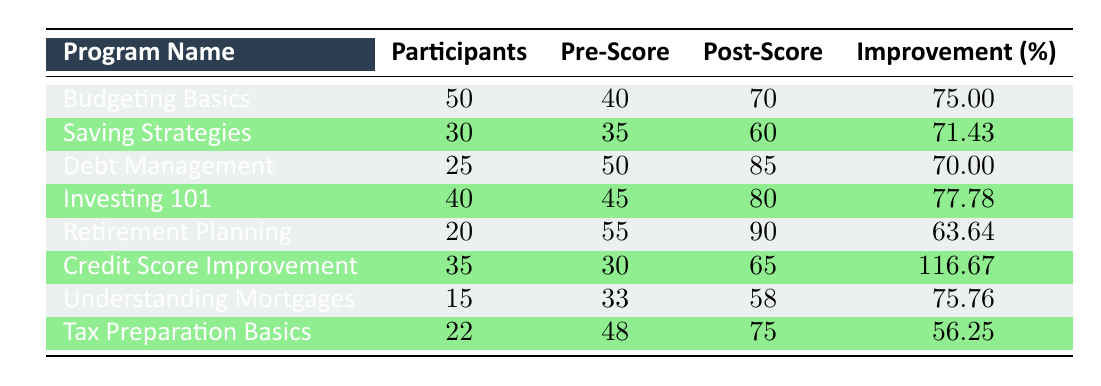What is the highest improvement percentage among the programs? The improvement percentages from the table are: Budgeting Basics (75.00), Saving Strategies (71.43), Debt Management (70.00), Investing 101 (77.78), Retirement Planning (63.64), Credit Score Improvement (116.67), Understanding Mortgages (75.76), and Tax Preparation Basics (56.25). The highest value is 116.67 from the Credit Score Improvement program.
Answer: 116.67 How many participants attended the Saving Strategies program? Looking at the table, the entry for Saving Strategies indicates that there were 30 participants.
Answer: 30 Did the Debt Management program have a post-assessment score higher than 80? From the table, the post-assessment score for the Debt Management program is 85, which is indeed higher than 80.
Answer: Yes What is the average improvement percentage of all the programs listed? First, sum up all the improvement percentages: 75.00 + 71.43 + 70.00 + 77.78 + 63.64 + 116.67 + 75.76 + 56.25 = 606.53. There are 8 programs, so the average improvement percentage is 606.53 / 8 = 75.82.
Answer: 75.82 Which program had the lowest pre-assessment score? By examining the pre-assessment scores, the scores are: Budgeting Basics (40), Saving Strategies (35), Debt Management (50), Investing 101 (45), Retirement Planning (55), Credit Score Improvement (30), Understanding Mortgages (33), and Tax Preparation Basics (48). The lowest score is 30 from the Credit Score Improvement program.
Answer: Credit Score Improvement What is the difference between the highest and lowest post-assessment scores? The highest post-assessment score is from Debt Management with 85, and the lowest is from Tax Preparation Basics with 75. The difference is calculated as 85 - 75 = 10.
Answer: 10 Did the Investing 101 program have an improvement percentage below 70? Looking at the data, Investing 101 has an improvement percentage of 77.78, which is above 70.
Answer: No How many programs had more than 40 participants? From the table, the programs with more than 40 participants are: Budgeting Basics (50), Investing 101 (40), and Credit Score Improvement (35). The programs with more than 40 participants are Budgeting Basics (50) only. Thus, there is one program with more than 40 participants.
Answer: 1 